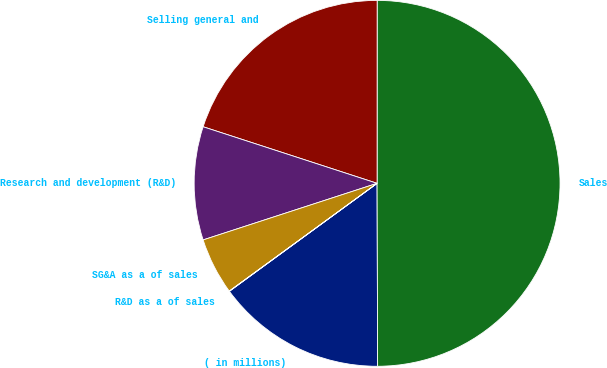Convert chart. <chart><loc_0><loc_0><loc_500><loc_500><pie_chart><fcel>( in millions)<fcel>Sales<fcel>Selling general and<fcel>Research and development (R&D)<fcel>SG&A as a of sales<fcel>R&D as a of sales<nl><fcel>15.0%<fcel>49.95%<fcel>20.0%<fcel>10.01%<fcel>5.02%<fcel>0.02%<nl></chart> 